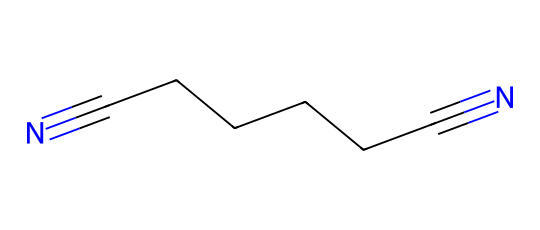What is the name of this chemical? The SMILES representation indicates the presence of a nitrogen triple bond at both ends of a six-carbon chain, characteristic of adiponitrile, which is commonly used in nylon production.
Answer: adiponitrile How many carbon atoms are present in this molecule? Counting the number of carbon atoms in the chain represented in the SMILES notation (CCCCCC) reveals there are six carbon atoms.
Answer: six What type of functional groups are present in adiponitrile? The presence of two nitrogen triple bonds (nitrile groups) at both ends suggests the functional groups in this chemical are nitriles.
Answer: nitriles What is the total number of nitrogen atoms in this molecule? The SMILES structure shows two occurrences of nitrogen (indicated as "N#"), leading to a total count of two nitrogen atoms.
Answer: two How does the structure of adiponitrile influence its use in art installations? The linear structure (due to the carbon chain and terminal nitriles) allows for flexibility and strength in materials, making it suitable for diverse artistic applications.
Answer: flexibility and strength What property of nitriles is indicated by the presence of the carbon-nitrogen triple bond? The carbon-nitrogen triple bond contributes to the polarity of the nitrile, which influences the solubility and reactivity of the compound in various environments.
Answer: polarity 